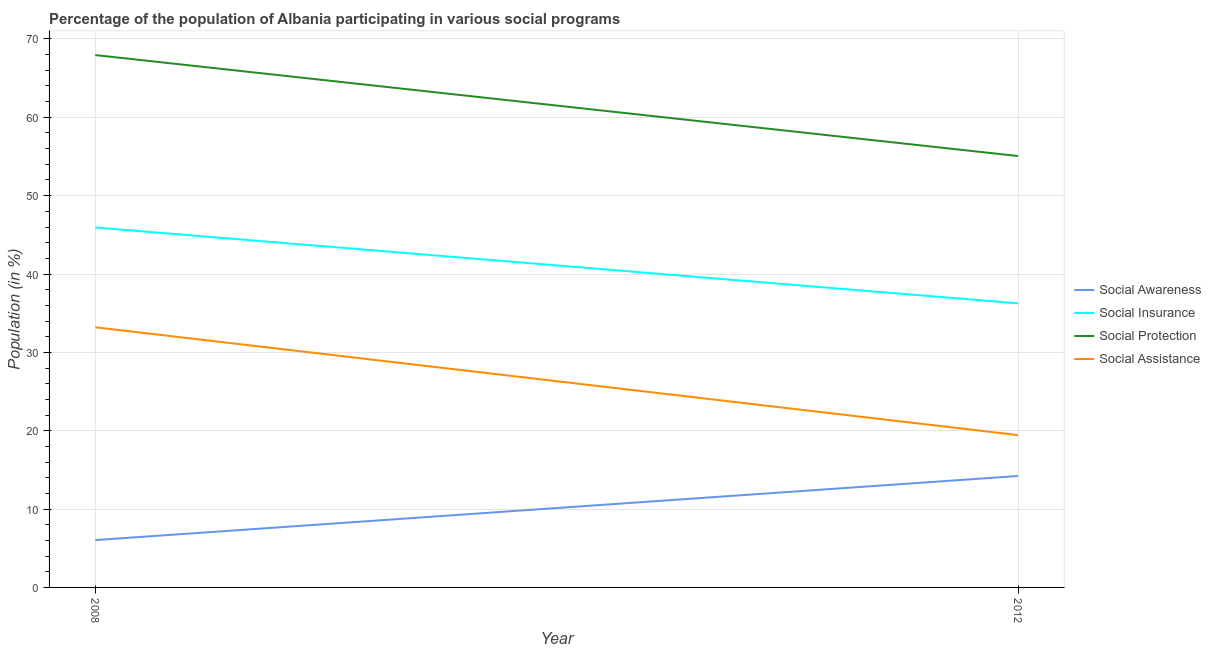Is the number of lines equal to the number of legend labels?
Your response must be concise. Yes. What is the participation of population in social assistance programs in 2008?
Provide a short and direct response. 33.2. Across all years, what is the maximum participation of population in social awareness programs?
Keep it short and to the point. 14.22. Across all years, what is the minimum participation of population in social protection programs?
Offer a very short reply. 55.06. In which year was the participation of population in social insurance programs maximum?
Give a very brief answer. 2008. What is the total participation of population in social insurance programs in the graph?
Provide a succinct answer. 82.19. What is the difference between the participation of population in social protection programs in 2008 and that in 2012?
Your answer should be compact. 12.89. What is the difference between the participation of population in social protection programs in 2012 and the participation of population in social insurance programs in 2008?
Your response must be concise. 9.12. What is the average participation of population in social awareness programs per year?
Offer a terse response. 10.13. In the year 2012, what is the difference between the participation of population in social protection programs and participation of population in social awareness programs?
Your response must be concise. 40.83. In how many years, is the participation of population in social insurance programs greater than 50 %?
Provide a short and direct response. 0. What is the ratio of the participation of population in social assistance programs in 2008 to that in 2012?
Your answer should be compact. 1.71. Is it the case that in every year, the sum of the participation of population in social awareness programs and participation of population in social assistance programs is greater than the sum of participation of population in social insurance programs and participation of population in social protection programs?
Make the answer very short. Yes. Is the participation of population in social assistance programs strictly less than the participation of population in social awareness programs over the years?
Provide a succinct answer. No. How many lines are there?
Offer a terse response. 4. How many years are there in the graph?
Your answer should be very brief. 2. What is the difference between two consecutive major ticks on the Y-axis?
Provide a short and direct response. 10. Does the graph contain any zero values?
Offer a terse response. No. How are the legend labels stacked?
Provide a short and direct response. Vertical. What is the title of the graph?
Provide a succinct answer. Percentage of the population of Albania participating in various social programs . Does "Offering training" appear as one of the legend labels in the graph?
Your answer should be very brief. No. What is the label or title of the Y-axis?
Ensure brevity in your answer.  Population (in %). What is the Population (in %) in Social Awareness in 2008?
Provide a short and direct response. 6.04. What is the Population (in %) in Social Insurance in 2008?
Make the answer very short. 45.94. What is the Population (in %) of Social Protection in 2008?
Provide a short and direct response. 67.94. What is the Population (in %) of Social Assistance in 2008?
Your response must be concise. 33.2. What is the Population (in %) of Social Awareness in 2012?
Ensure brevity in your answer.  14.22. What is the Population (in %) in Social Insurance in 2012?
Provide a short and direct response. 36.26. What is the Population (in %) of Social Protection in 2012?
Offer a terse response. 55.06. What is the Population (in %) in Social Assistance in 2012?
Keep it short and to the point. 19.44. Across all years, what is the maximum Population (in %) of Social Awareness?
Your answer should be very brief. 14.22. Across all years, what is the maximum Population (in %) of Social Insurance?
Ensure brevity in your answer.  45.94. Across all years, what is the maximum Population (in %) in Social Protection?
Your response must be concise. 67.94. Across all years, what is the maximum Population (in %) of Social Assistance?
Your response must be concise. 33.2. Across all years, what is the minimum Population (in %) of Social Awareness?
Offer a very short reply. 6.04. Across all years, what is the minimum Population (in %) of Social Insurance?
Keep it short and to the point. 36.26. Across all years, what is the minimum Population (in %) of Social Protection?
Your response must be concise. 55.06. Across all years, what is the minimum Population (in %) of Social Assistance?
Make the answer very short. 19.44. What is the total Population (in %) of Social Awareness in the graph?
Keep it short and to the point. 20.26. What is the total Population (in %) in Social Insurance in the graph?
Make the answer very short. 82.19. What is the total Population (in %) of Social Protection in the graph?
Your answer should be compact. 123. What is the total Population (in %) of Social Assistance in the graph?
Make the answer very short. 52.64. What is the difference between the Population (in %) in Social Awareness in 2008 and that in 2012?
Keep it short and to the point. -8.18. What is the difference between the Population (in %) in Social Insurance in 2008 and that in 2012?
Offer a terse response. 9.68. What is the difference between the Population (in %) in Social Protection in 2008 and that in 2012?
Give a very brief answer. 12.89. What is the difference between the Population (in %) of Social Assistance in 2008 and that in 2012?
Your answer should be compact. 13.76. What is the difference between the Population (in %) in Social Awareness in 2008 and the Population (in %) in Social Insurance in 2012?
Ensure brevity in your answer.  -30.21. What is the difference between the Population (in %) of Social Awareness in 2008 and the Population (in %) of Social Protection in 2012?
Your response must be concise. -49.01. What is the difference between the Population (in %) of Social Awareness in 2008 and the Population (in %) of Social Assistance in 2012?
Keep it short and to the point. -13.4. What is the difference between the Population (in %) in Social Insurance in 2008 and the Population (in %) in Social Protection in 2012?
Offer a very short reply. -9.12. What is the difference between the Population (in %) in Social Insurance in 2008 and the Population (in %) in Social Assistance in 2012?
Keep it short and to the point. 26.5. What is the difference between the Population (in %) in Social Protection in 2008 and the Population (in %) in Social Assistance in 2012?
Keep it short and to the point. 48.5. What is the average Population (in %) in Social Awareness per year?
Offer a very short reply. 10.13. What is the average Population (in %) in Social Insurance per year?
Your answer should be very brief. 41.1. What is the average Population (in %) in Social Protection per year?
Ensure brevity in your answer.  61.5. What is the average Population (in %) in Social Assistance per year?
Your response must be concise. 26.32. In the year 2008, what is the difference between the Population (in %) in Social Awareness and Population (in %) in Social Insurance?
Provide a succinct answer. -39.9. In the year 2008, what is the difference between the Population (in %) in Social Awareness and Population (in %) in Social Protection?
Give a very brief answer. -61.9. In the year 2008, what is the difference between the Population (in %) in Social Awareness and Population (in %) in Social Assistance?
Your answer should be compact. -27.16. In the year 2008, what is the difference between the Population (in %) in Social Insurance and Population (in %) in Social Protection?
Your answer should be compact. -22. In the year 2008, what is the difference between the Population (in %) of Social Insurance and Population (in %) of Social Assistance?
Offer a terse response. 12.74. In the year 2008, what is the difference between the Population (in %) in Social Protection and Population (in %) in Social Assistance?
Keep it short and to the point. 34.74. In the year 2012, what is the difference between the Population (in %) in Social Awareness and Population (in %) in Social Insurance?
Your answer should be very brief. -22.03. In the year 2012, what is the difference between the Population (in %) in Social Awareness and Population (in %) in Social Protection?
Keep it short and to the point. -40.83. In the year 2012, what is the difference between the Population (in %) in Social Awareness and Population (in %) in Social Assistance?
Keep it short and to the point. -5.22. In the year 2012, what is the difference between the Population (in %) of Social Insurance and Population (in %) of Social Protection?
Your answer should be compact. -18.8. In the year 2012, what is the difference between the Population (in %) of Social Insurance and Population (in %) of Social Assistance?
Keep it short and to the point. 16.81. In the year 2012, what is the difference between the Population (in %) of Social Protection and Population (in %) of Social Assistance?
Keep it short and to the point. 35.62. What is the ratio of the Population (in %) of Social Awareness in 2008 to that in 2012?
Your answer should be compact. 0.42. What is the ratio of the Population (in %) of Social Insurance in 2008 to that in 2012?
Your answer should be very brief. 1.27. What is the ratio of the Population (in %) in Social Protection in 2008 to that in 2012?
Keep it short and to the point. 1.23. What is the ratio of the Population (in %) in Social Assistance in 2008 to that in 2012?
Provide a short and direct response. 1.71. What is the difference between the highest and the second highest Population (in %) in Social Awareness?
Make the answer very short. 8.18. What is the difference between the highest and the second highest Population (in %) of Social Insurance?
Give a very brief answer. 9.68. What is the difference between the highest and the second highest Population (in %) in Social Protection?
Your answer should be very brief. 12.89. What is the difference between the highest and the second highest Population (in %) of Social Assistance?
Offer a very short reply. 13.76. What is the difference between the highest and the lowest Population (in %) of Social Awareness?
Provide a succinct answer. 8.18. What is the difference between the highest and the lowest Population (in %) of Social Insurance?
Provide a short and direct response. 9.68. What is the difference between the highest and the lowest Population (in %) in Social Protection?
Give a very brief answer. 12.89. What is the difference between the highest and the lowest Population (in %) of Social Assistance?
Your answer should be very brief. 13.76. 